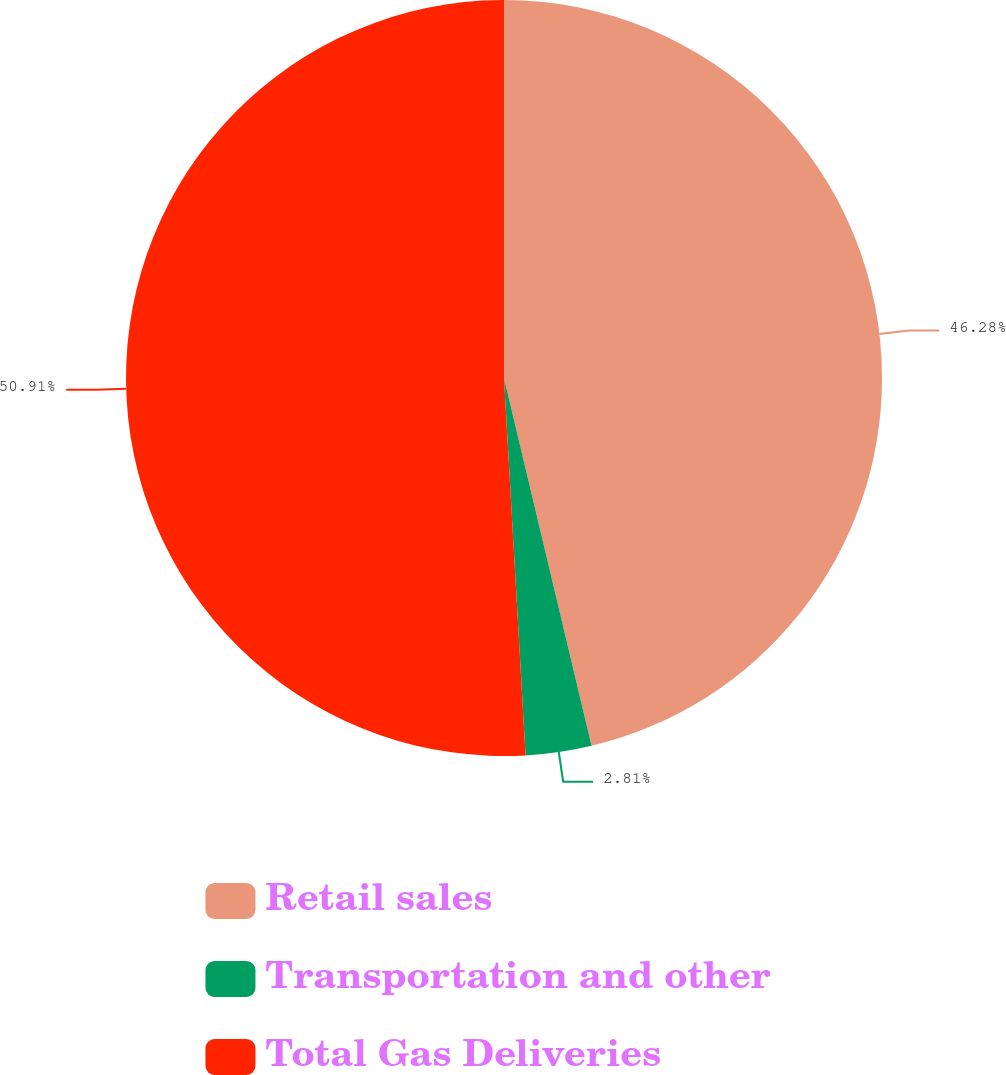Convert chart to OTSL. <chart><loc_0><loc_0><loc_500><loc_500><pie_chart><fcel>Retail sales<fcel>Transportation and other<fcel>Total Gas Deliveries<nl><fcel>46.28%<fcel>2.81%<fcel>50.91%<nl></chart> 